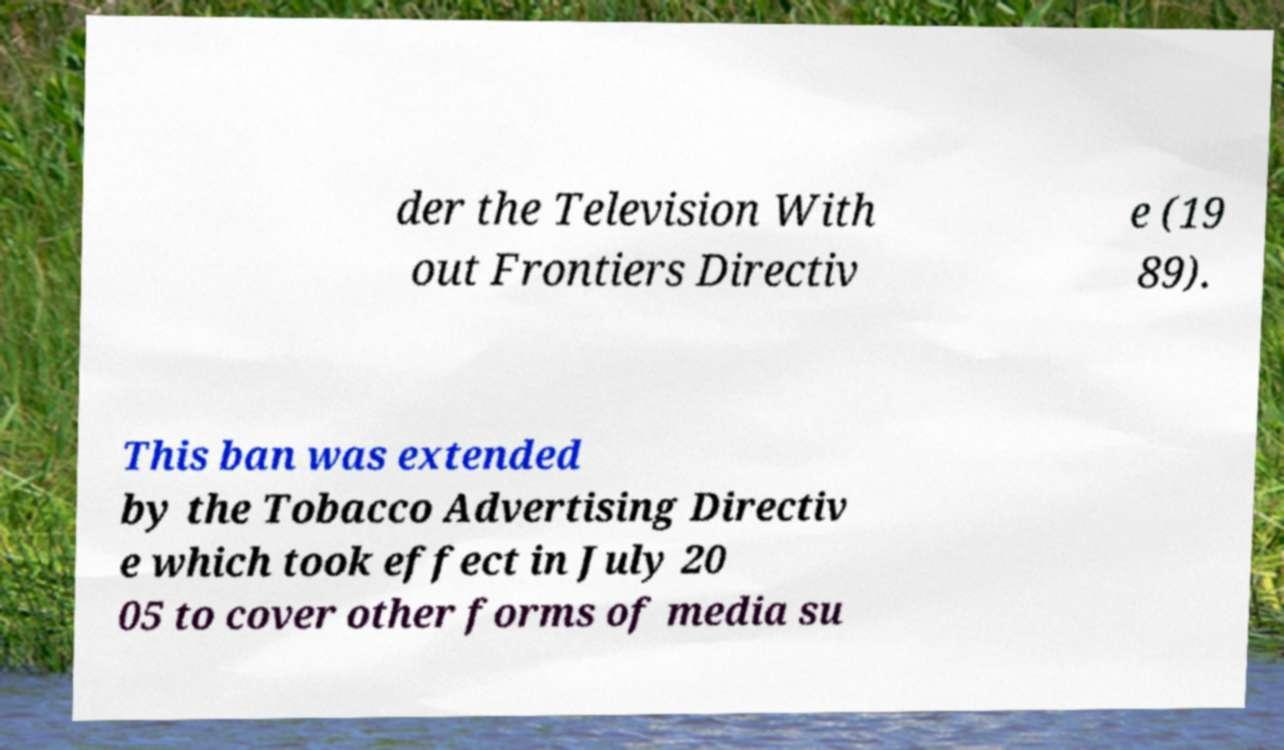Can you accurately transcribe the text from the provided image for me? der the Television With out Frontiers Directiv e (19 89). This ban was extended by the Tobacco Advertising Directiv e which took effect in July 20 05 to cover other forms of media su 